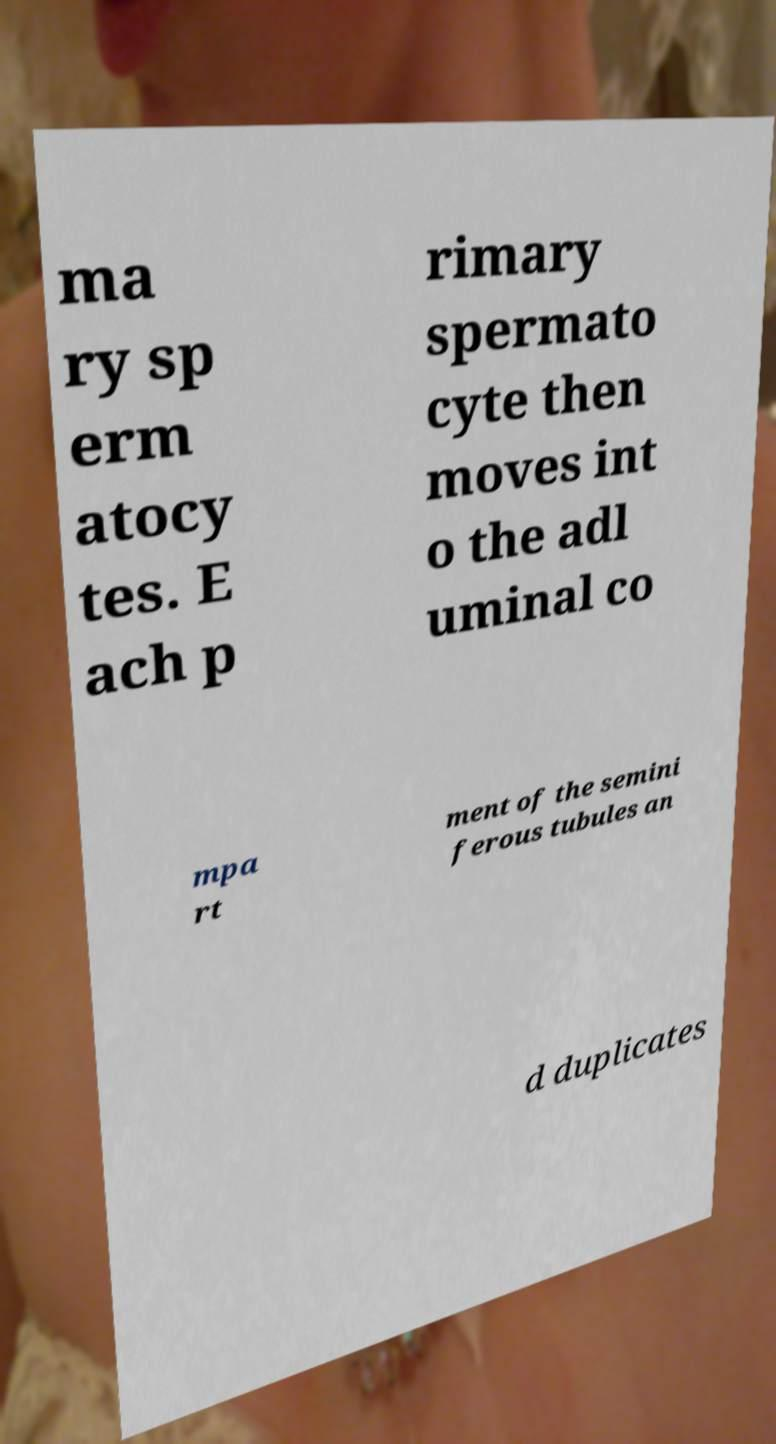Please identify and transcribe the text found in this image. ma ry sp erm atocy tes. E ach p rimary spermato cyte then moves int o the adl uminal co mpa rt ment of the semini ferous tubules an d duplicates 